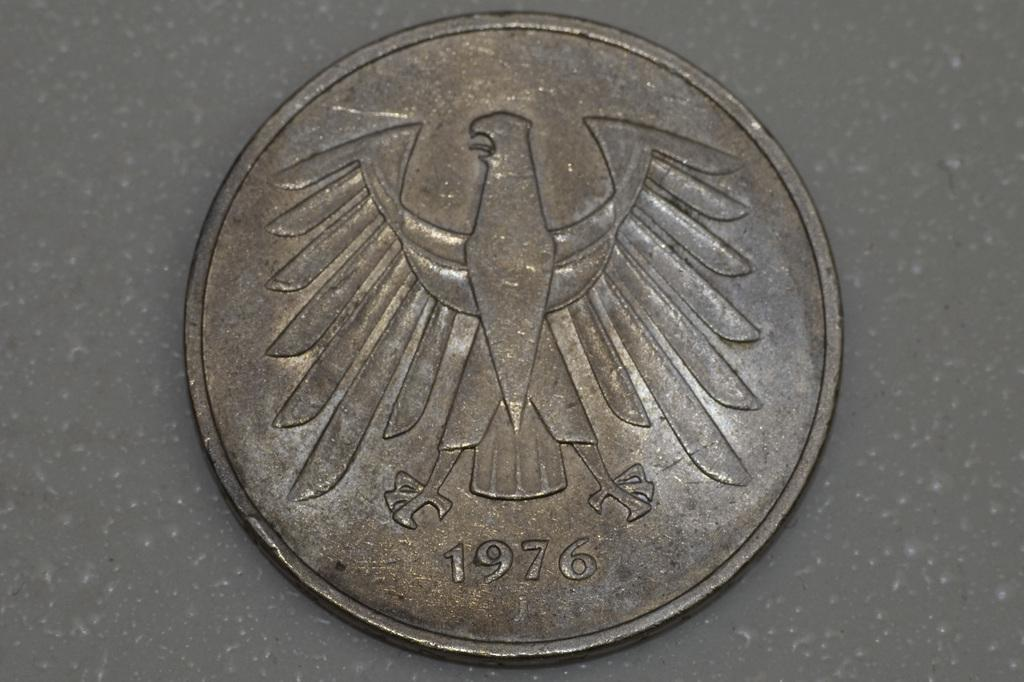Provide a one-sentence caption for the provided image. An old coin from 1976 that has an eagle emblem on it. 